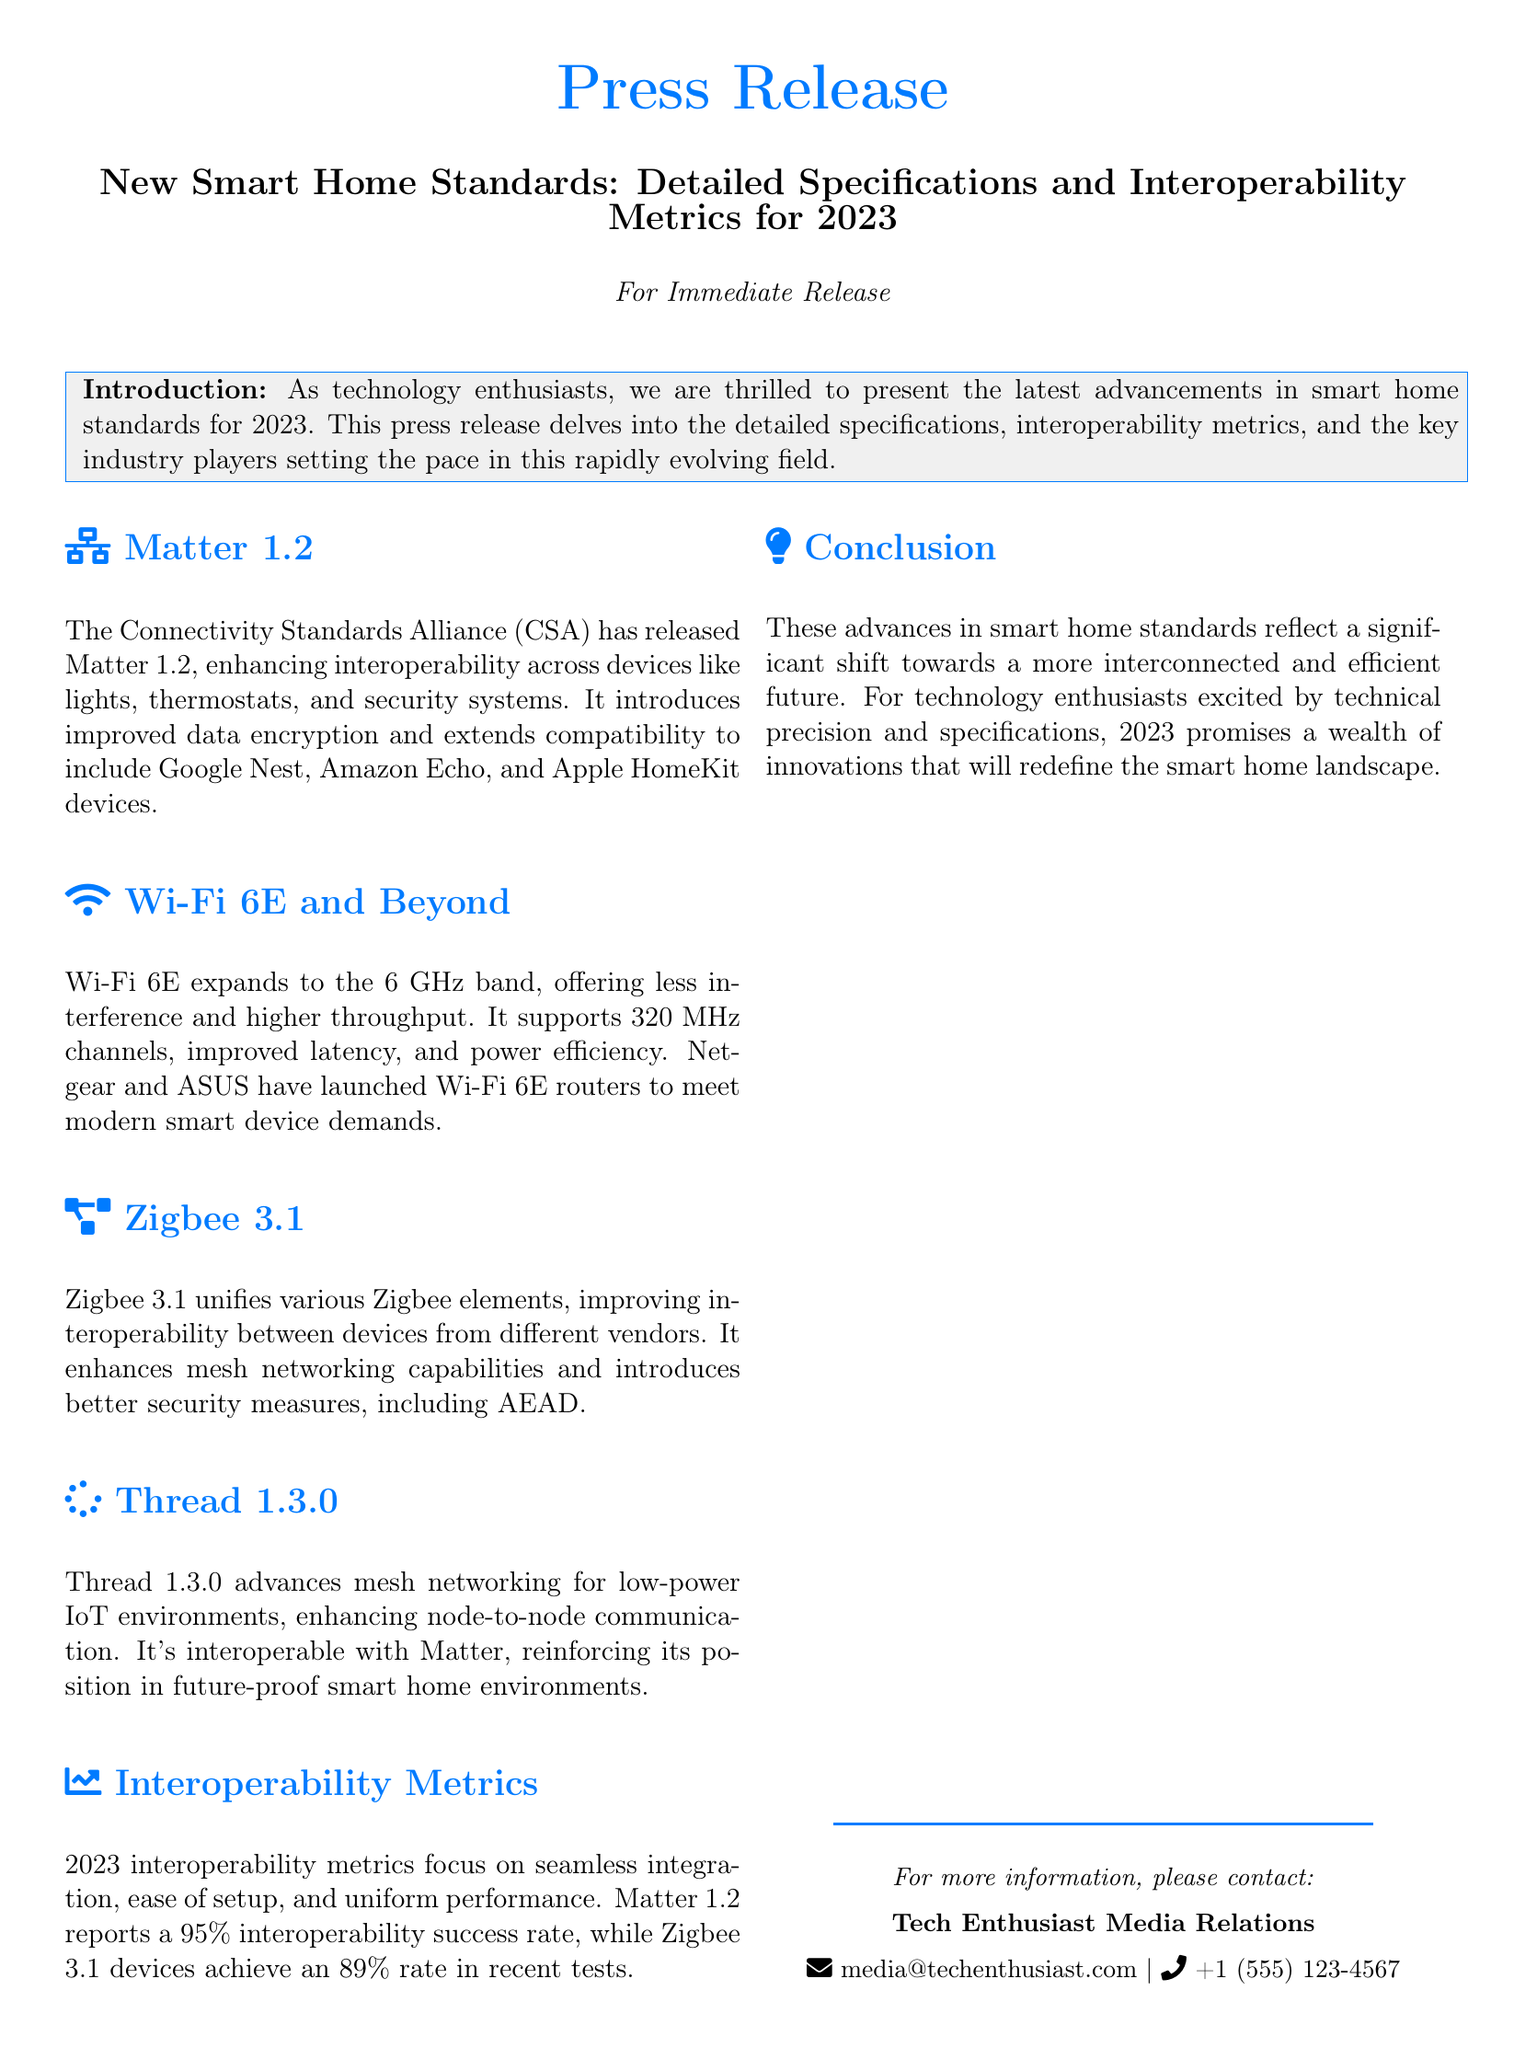what is the title of the press release? The title of the press release is stated in the header section of the document.
Answer: New Smart Home Standards: Detailed Specifications and Interoperability Metrics for 2023 who released Matter 1.2? It is mentioned that the Connectivity Standards Alliance has released Matter 1.2.
Answer: Connectivity Standards Alliance what percentage of interoperability success does Matter 1.2 report? The document specifies the interoperability success rate for Matter 1.2.
Answer: 95% which technology expands to the 6 GHz band? The document lists Wi-Fi 6E as expanding to the 6 GHz band.
Answer: Wi-Fi 6E what is the primary focus of the 2023 interoperability metrics? The press release emphasizes certain objectives related to the interoperability metrics.
Answer: Seamless integration which company launched Wi-Fi 6E routers? The document mentions specific companies that have launched routers in this category.
Answer: Netgear and ASUS what does Thread 1.3.0 enhance? The document states what Thread 1.3.0 improves in smart home environments.
Answer: Mesh networking what is the purpose of the press release? The introduction clarifies the objective of the press release in the context of smart home technology.
Answer: Present the latest advancements in smart home standards 